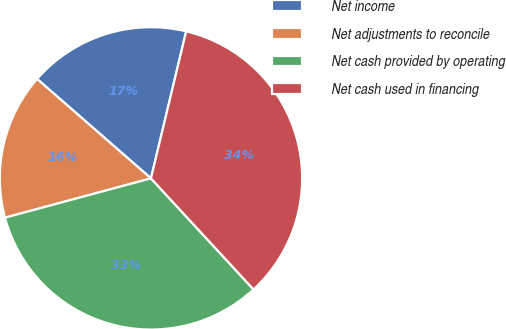<chart> <loc_0><loc_0><loc_500><loc_500><pie_chart><fcel>Net income<fcel>Net adjustments to reconcile<fcel>Net cash provided by operating<fcel>Net cash used in financing<nl><fcel>17.32%<fcel>15.61%<fcel>32.68%<fcel>34.39%<nl></chart> 